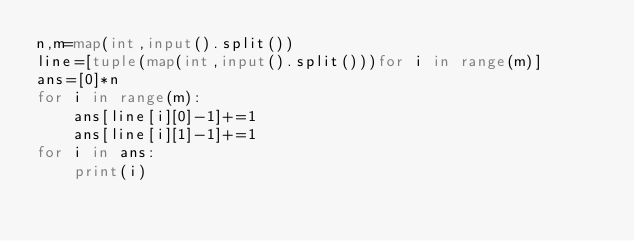<code> <loc_0><loc_0><loc_500><loc_500><_Python_>n,m=map(int,input().split())
line=[tuple(map(int,input().split()))for i in range(m)]
ans=[0]*n
for i in range(m):
    ans[line[i][0]-1]+=1
    ans[line[i][1]-1]+=1
for i in ans:
    print(i)

</code> 